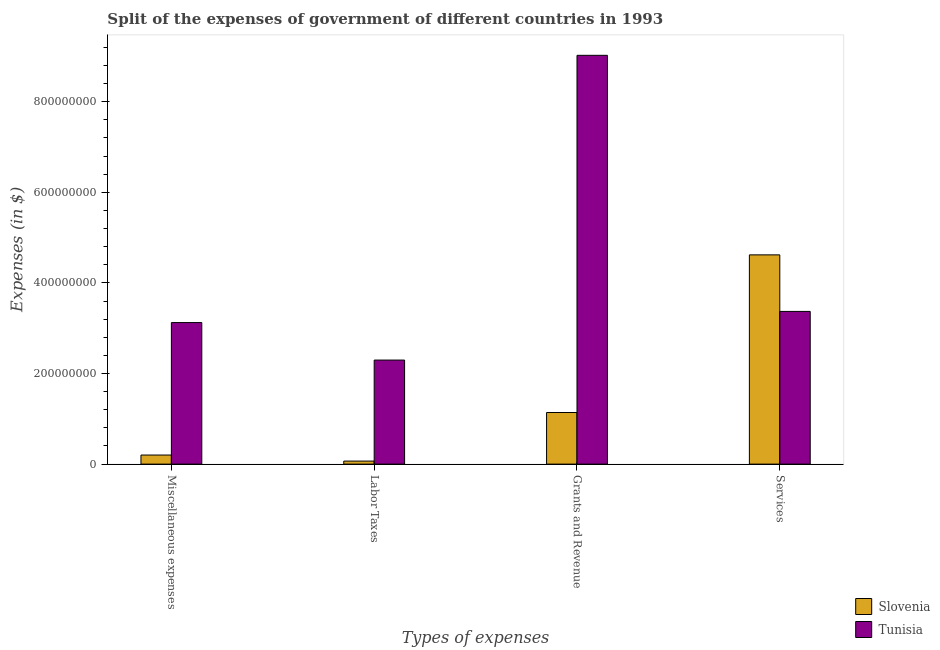How many different coloured bars are there?
Provide a succinct answer. 2. Are the number of bars per tick equal to the number of legend labels?
Your response must be concise. Yes. Are the number of bars on each tick of the X-axis equal?
Make the answer very short. Yes. What is the label of the 3rd group of bars from the left?
Your response must be concise. Grants and Revenue. What is the amount spent on services in Slovenia?
Offer a very short reply. 4.62e+08. Across all countries, what is the maximum amount spent on grants and revenue?
Ensure brevity in your answer.  9.02e+08. Across all countries, what is the minimum amount spent on labor taxes?
Offer a terse response. 6.68e+06. In which country was the amount spent on grants and revenue maximum?
Provide a short and direct response. Tunisia. In which country was the amount spent on grants and revenue minimum?
Your answer should be compact. Slovenia. What is the total amount spent on grants and revenue in the graph?
Your answer should be very brief. 1.02e+09. What is the difference between the amount spent on labor taxes in Slovenia and that in Tunisia?
Give a very brief answer. -2.23e+08. What is the difference between the amount spent on miscellaneous expenses in Slovenia and the amount spent on grants and revenue in Tunisia?
Offer a very short reply. -8.82e+08. What is the average amount spent on miscellaneous expenses per country?
Give a very brief answer. 1.66e+08. What is the difference between the amount spent on services and amount spent on grants and revenue in Slovenia?
Your answer should be compact. 3.48e+08. What is the ratio of the amount spent on labor taxes in Slovenia to that in Tunisia?
Your answer should be very brief. 0.03. Is the difference between the amount spent on services in Tunisia and Slovenia greater than the difference between the amount spent on miscellaneous expenses in Tunisia and Slovenia?
Keep it short and to the point. No. What is the difference between the highest and the second highest amount spent on labor taxes?
Give a very brief answer. 2.23e+08. What is the difference between the highest and the lowest amount spent on miscellaneous expenses?
Ensure brevity in your answer.  2.92e+08. Is the sum of the amount spent on services in Tunisia and Slovenia greater than the maximum amount spent on miscellaneous expenses across all countries?
Ensure brevity in your answer.  Yes. Is it the case that in every country, the sum of the amount spent on services and amount spent on labor taxes is greater than the sum of amount spent on grants and revenue and amount spent on miscellaneous expenses?
Provide a succinct answer. Yes. What does the 1st bar from the left in Grants and Revenue represents?
Your answer should be very brief. Slovenia. What does the 1st bar from the right in Grants and Revenue represents?
Offer a very short reply. Tunisia. Is it the case that in every country, the sum of the amount spent on miscellaneous expenses and amount spent on labor taxes is greater than the amount spent on grants and revenue?
Give a very brief answer. No. How many bars are there?
Your response must be concise. 8. How many countries are there in the graph?
Give a very brief answer. 2. Does the graph contain any zero values?
Your response must be concise. No. Does the graph contain grids?
Make the answer very short. No. What is the title of the graph?
Make the answer very short. Split of the expenses of government of different countries in 1993. What is the label or title of the X-axis?
Keep it short and to the point. Types of expenses. What is the label or title of the Y-axis?
Provide a short and direct response. Expenses (in $). What is the Expenses (in $) in Slovenia in Miscellaneous expenses?
Offer a very short reply. 2.00e+07. What is the Expenses (in $) of Tunisia in Miscellaneous expenses?
Provide a succinct answer. 3.12e+08. What is the Expenses (in $) of Slovenia in Labor Taxes?
Offer a terse response. 6.68e+06. What is the Expenses (in $) of Tunisia in Labor Taxes?
Offer a terse response. 2.30e+08. What is the Expenses (in $) of Slovenia in Grants and Revenue?
Make the answer very short. 1.14e+08. What is the Expenses (in $) in Tunisia in Grants and Revenue?
Your answer should be very brief. 9.02e+08. What is the Expenses (in $) in Slovenia in Services?
Offer a very short reply. 4.62e+08. What is the Expenses (in $) of Tunisia in Services?
Your answer should be compact. 3.37e+08. Across all Types of expenses, what is the maximum Expenses (in $) of Slovenia?
Give a very brief answer. 4.62e+08. Across all Types of expenses, what is the maximum Expenses (in $) of Tunisia?
Give a very brief answer. 9.02e+08. Across all Types of expenses, what is the minimum Expenses (in $) of Slovenia?
Your answer should be very brief. 6.68e+06. Across all Types of expenses, what is the minimum Expenses (in $) in Tunisia?
Ensure brevity in your answer.  2.30e+08. What is the total Expenses (in $) of Slovenia in the graph?
Give a very brief answer. 6.03e+08. What is the total Expenses (in $) in Tunisia in the graph?
Ensure brevity in your answer.  1.78e+09. What is the difference between the Expenses (in $) of Slovenia in Miscellaneous expenses and that in Labor Taxes?
Make the answer very short. 1.34e+07. What is the difference between the Expenses (in $) in Tunisia in Miscellaneous expenses and that in Labor Taxes?
Keep it short and to the point. 8.28e+07. What is the difference between the Expenses (in $) of Slovenia in Miscellaneous expenses and that in Grants and Revenue?
Offer a very short reply. -9.39e+07. What is the difference between the Expenses (in $) of Tunisia in Miscellaneous expenses and that in Grants and Revenue?
Ensure brevity in your answer.  -5.90e+08. What is the difference between the Expenses (in $) in Slovenia in Miscellaneous expenses and that in Services?
Offer a terse response. -4.42e+08. What is the difference between the Expenses (in $) of Tunisia in Miscellaneous expenses and that in Services?
Make the answer very short. -2.46e+07. What is the difference between the Expenses (in $) in Slovenia in Labor Taxes and that in Grants and Revenue?
Offer a very short reply. -1.07e+08. What is the difference between the Expenses (in $) of Tunisia in Labor Taxes and that in Grants and Revenue?
Ensure brevity in your answer.  -6.73e+08. What is the difference between the Expenses (in $) in Slovenia in Labor Taxes and that in Services?
Ensure brevity in your answer.  -4.55e+08. What is the difference between the Expenses (in $) of Tunisia in Labor Taxes and that in Services?
Your answer should be very brief. -1.07e+08. What is the difference between the Expenses (in $) of Slovenia in Grants and Revenue and that in Services?
Ensure brevity in your answer.  -3.48e+08. What is the difference between the Expenses (in $) of Tunisia in Grants and Revenue and that in Services?
Offer a terse response. 5.65e+08. What is the difference between the Expenses (in $) of Slovenia in Miscellaneous expenses and the Expenses (in $) of Tunisia in Labor Taxes?
Provide a succinct answer. -2.10e+08. What is the difference between the Expenses (in $) in Slovenia in Miscellaneous expenses and the Expenses (in $) in Tunisia in Grants and Revenue?
Provide a short and direct response. -8.82e+08. What is the difference between the Expenses (in $) of Slovenia in Miscellaneous expenses and the Expenses (in $) of Tunisia in Services?
Provide a succinct answer. -3.17e+08. What is the difference between the Expenses (in $) in Slovenia in Labor Taxes and the Expenses (in $) in Tunisia in Grants and Revenue?
Give a very brief answer. -8.96e+08. What is the difference between the Expenses (in $) in Slovenia in Labor Taxes and the Expenses (in $) in Tunisia in Services?
Your answer should be very brief. -3.30e+08. What is the difference between the Expenses (in $) of Slovenia in Grants and Revenue and the Expenses (in $) of Tunisia in Services?
Your answer should be compact. -2.23e+08. What is the average Expenses (in $) of Slovenia per Types of expenses?
Your answer should be compact. 1.51e+08. What is the average Expenses (in $) of Tunisia per Types of expenses?
Your answer should be very brief. 4.45e+08. What is the difference between the Expenses (in $) of Slovenia and Expenses (in $) of Tunisia in Miscellaneous expenses?
Your answer should be very brief. -2.92e+08. What is the difference between the Expenses (in $) of Slovenia and Expenses (in $) of Tunisia in Labor Taxes?
Your answer should be compact. -2.23e+08. What is the difference between the Expenses (in $) of Slovenia and Expenses (in $) of Tunisia in Grants and Revenue?
Your answer should be very brief. -7.89e+08. What is the difference between the Expenses (in $) of Slovenia and Expenses (in $) of Tunisia in Services?
Keep it short and to the point. 1.25e+08. What is the ratio of the Expenses (in $) in Slovenia in Miscellaneous expenses to that in Labor Taxes?
Give a very brief answer. 3. What is the ratio of the Expenses (in $) of Tunisia in Miscellaneous expenses to that in Labor Taxes?
Offer a terse response. 1.36. What is the ratio of the Expenses (in $) of Slovenia in Miscellaneous expenses to that in Grants and Revenue?
Offer a very short reply. 0.18. What is the ratio of the Expenses (in $) of Tunisia in Miscellaneous expenses to that in Grants and Revenue?
Keep it short and to the point. 0.35. What is the ratio of the Expenses (in $) in Slovenia in Miscellaneous expenses to that in Services?
Provide a succinct answer. 0.04. What is the ratio of the Expenses (in $) in Tunisia in Miscellaneous expenses to that in Services?
Provide a short and direct response. 0.93. What is the ratio of the Expenses (in $) in Slovenia in Labor Taxes to that in Grants and Revenue?
Offer a terse response. 0.06. What is the ratio of the Expenses (in $) of Tunisia in Labor Taxes to that in Grants and Revenue?
Your answer should be very brief. 0.25. What is the ratio of the Expenses (in $) in Slovenia in Labor Taxes to that in Services?
Provide a succinct answer. 0.01. What is the ratio of the Expenses (in $) in Tunisia in Labor Taxes to that in Services?
Ensure brevity in your answer.  0.68. What is the ratio of the Expenses (in $) of Slovenia in Grants and Revenue to that in Services?
Ensure brevity in your answer.  0.25. What is the ratio of the Expenses (in $) in Tunisia in Grants and Revenue to that in Services?
Give a very brief answer. 2.68. What is the difference between the highest and the second highest Expenses (in $) in Slovenia?
Give a very brief answer. 3.48e+08. What is the difference between the highest and the second highest Expenses (in $) in Tunisia?
Keep it short and to the point. 5.65e+08. What is the difference between the highest and the lowest Expenses (in $) of Slovenia?
Provide a short and direct response. 4.55e+08. What is the difference between the highest and the lowest Expenses (in $) of Tunisia?
Give a very brief answer. 6.73e+08. 